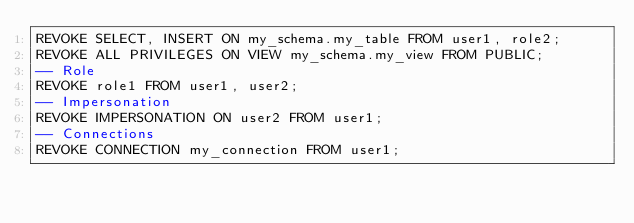Convert code to text. <code><loc_0><loc_0><loc_500><loc_500><_SQL_>REVOKE SELECT, INSERT ON my_schema.my_table FROM user1, role2;
REVOKE ALL PRIVILEGES ON VIEW my_schema.my_view FROM PUBLIC;
-- Role
REVOKE role1 FROM user1, user2;
-- Impersonation
REVOKE IMPERSONATION ON user2 FROM user1;
-- Connections
REVOKE CONNECTION my_connection FROM user1;
</code> 